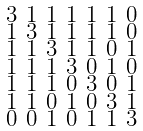Convert formula to latex. <formula><loc_0><loc_0><loc_500><loc_500>\begin{smallmatrix} 3 & 1 & 1 & 1 & 1 & 1 & 0 \\ 1 & 3 & 1 & 1 & 1 & 1 & 0 \\ 1 & 1 & 3 & 1 & 1 & 0 & 1 \\ 1 & 1 & 1 & 3 & 0 & 1 & 0 \\ 1 & 1 & 1 & 0 & 3 & 0 & 1 \\ 1 & 1 & 0 & 1 & 0 & 3 & 1 \\ 0 & 0 & 1 & 0 & 1 & 1 & 3 \end{smallmatrix}</formula> 